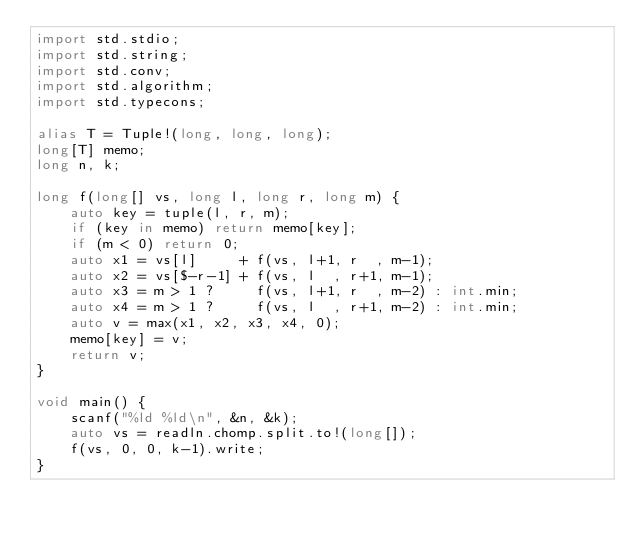Convert code to text. <code><loc_0><loc_0><loc_500><loc_500><_D_>import std.stdio;
import std.string;
import std.conv;
import std.algorithm;
import std.typecons;

alias T = Tuple!(long, long, long);
long[T] memo;
long n, k;

long f(long[] vs, long l, long r, long m) {
	auto key = tuple(l, r, m);
	if (key in memo) return memo[key];
	if (m < 0) return 0;
	auto x1 = vs[l]     + f(vs, l+1, r  , m-1);
	auto x2 = vs[$-r-1] + f(vs, l  , r+1, m-1);
	auto x3 = m > 1 ?     f(vs, l+1, r  , m-2) : int.min;
	auto x4 = m > 1 ?     f(vs, l  , r+1, m-2) : int.min;
	auto v = max(x1, x2, x3, x4, 0);
	memo[key] = v;
	return v;
}

void main() {
	scanf("%ld %ld\n", &n, &k);
	auto vs = readln.chomp.split.to!(long[]);
	f(vs, 0, 0, k-1).write;
}
</code> 